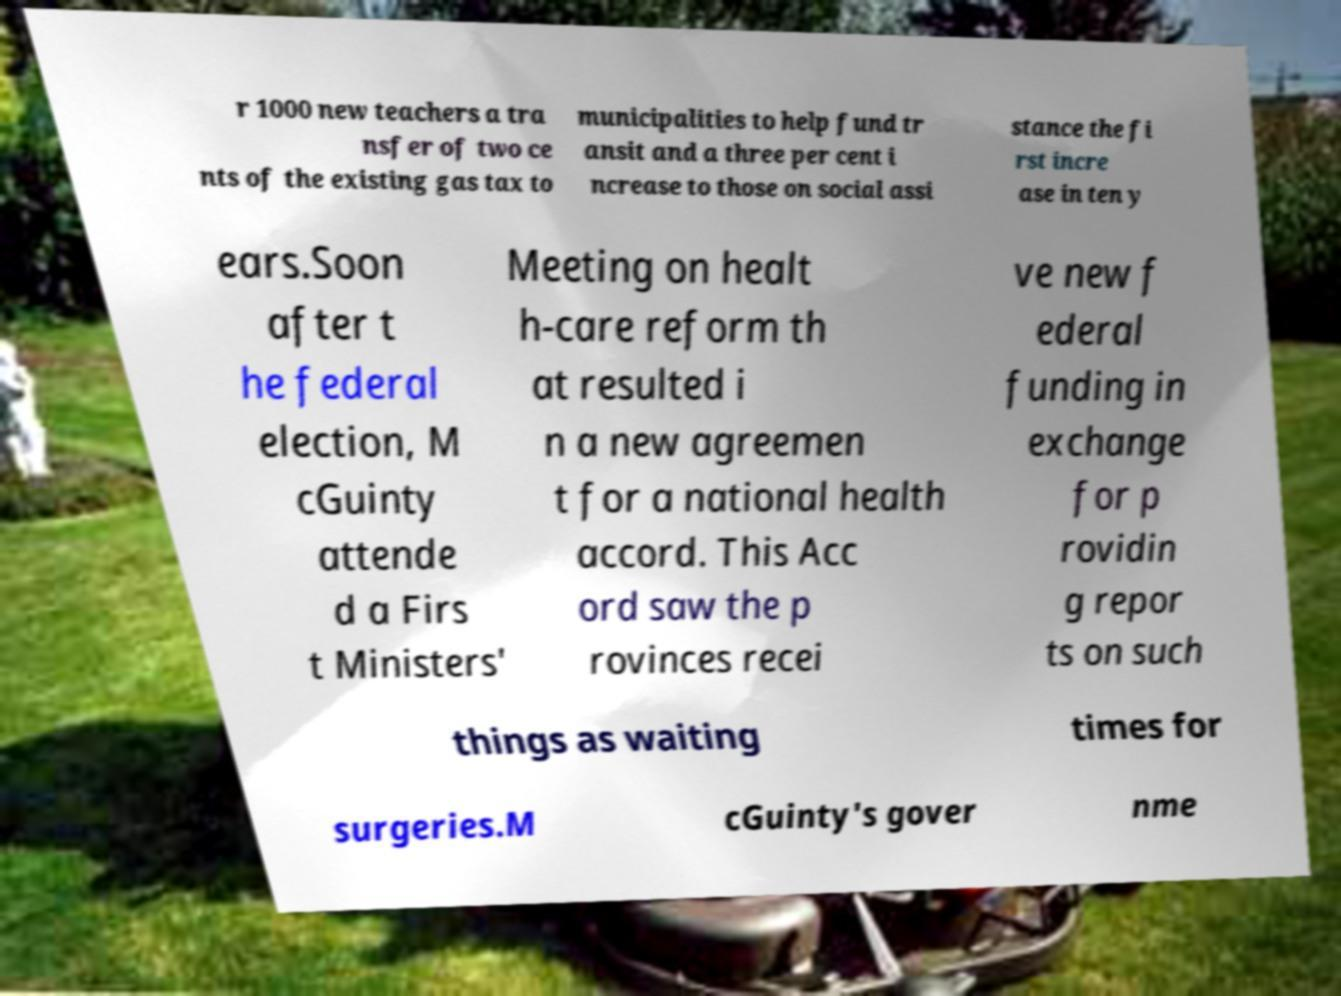Can you accurately transcribe the text from the provided image for me? r 1000 new teachers a tra nsfer of two ce nts of the existing gas tax to municipalities to help fund tr ansit and a three per cent i ncrease to those on social assi stance the fi rst incre ase in ten y ears.Soon after t he federal election, M cGuinty attende d a Firs t Ministers' Meeting on healt h-care reform th at resulted i n a new agreemen t for a national health accord. This Acc ord saw the p rovinces recei ve new f ederal funding in exchange for p rovidin g repor ts on such things as waiting times for surgeries.M cGuinty's gover nme 